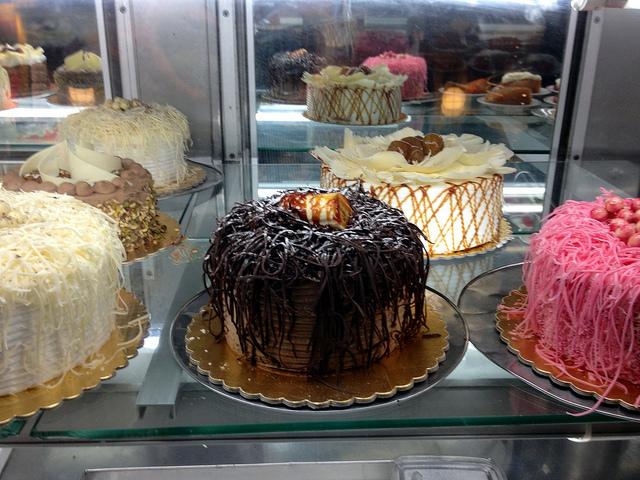Are these cakes for sale?
Give a very brief answer. Yes. How many cakes are pink?
Short answer required. 1. Have any of the cakes been cut yet?
Give a very brief answer. No. 